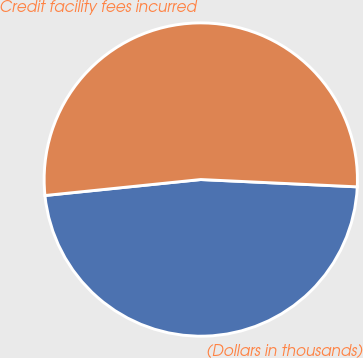Convert chart to OTSL. <chart><loc_0><loc_0><loc_500><loc_500><pie_chart><fcel>(Dollars in thousands)<fcel>Credit facility fees incurred<nl><fcel>47.63%<fcel>52.37%<nl></chart> 